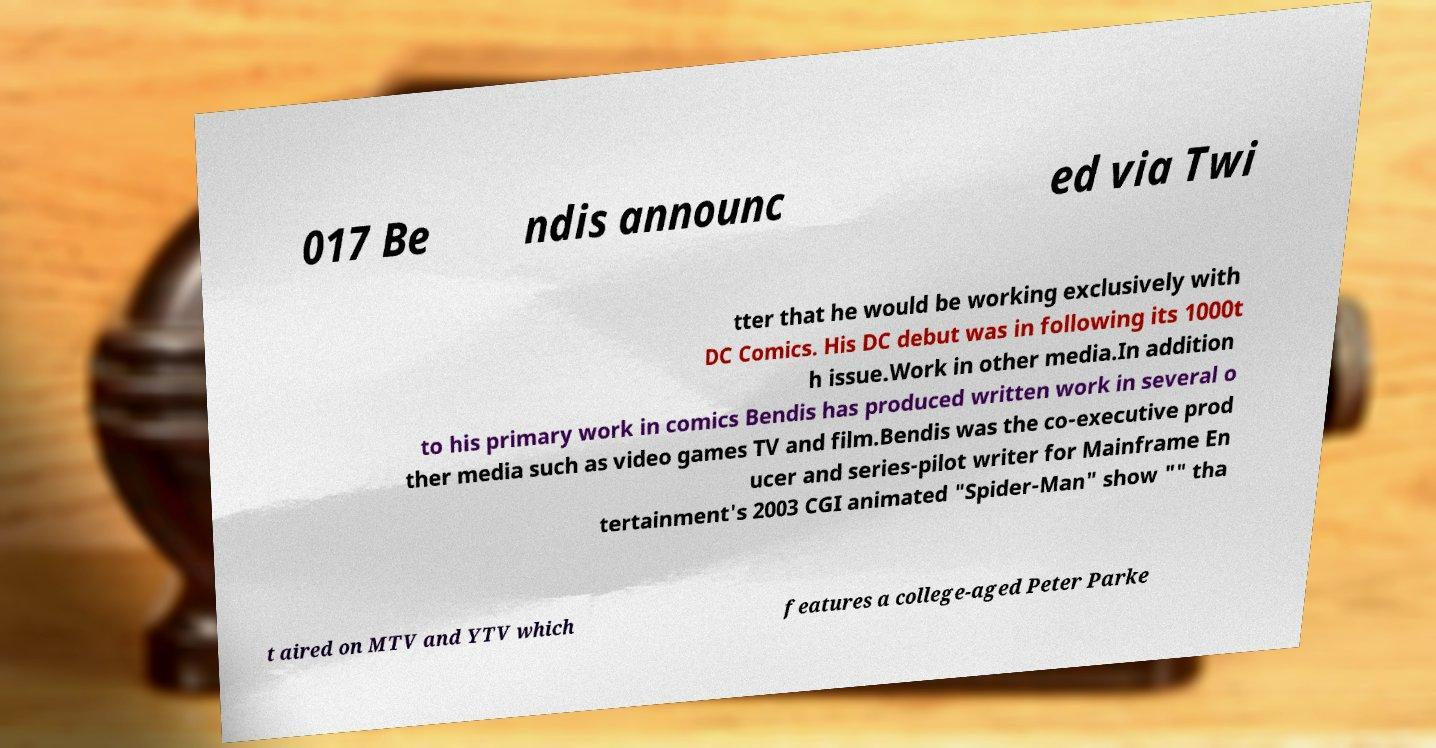Please read and relay the text visible in this image. What does it say? 017 Be ndis announc ed via Twi tter that he would be working exclusively with DC Comics. His DC debut was in following its 1000t h issue.Work in other media.In addition to his primary work in comics Bendis has produced written work in several o ther media such as video games TV and film.Bendis was the co-executive prod ucer and series-pilot writer for Mainframe En tertainment's 2003 CGI animated "Spider-Man" show "" tha t aired on MTV and YTV which features a college-aged Peter Parke 